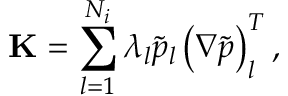<formula> <loc_0><loc_0><loc_500><loc_500>K = \sum _ { l = 1 } ^ { N _ { i } } \lambda _ { l } \tilde { p } _ { l } \left ( \nabla \tilde { p } \right ) _ { l } ^ { T } ,</formula> 